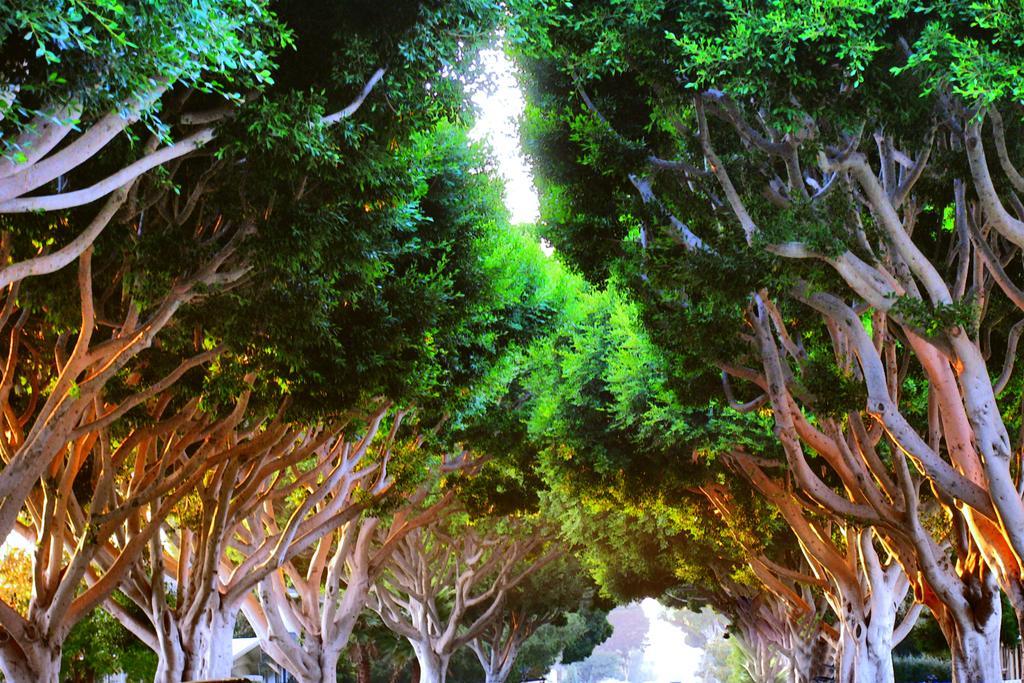How would you summarize this image in a sentence or two? In this picture we can see trees, there is the sky at the top of the picture. 